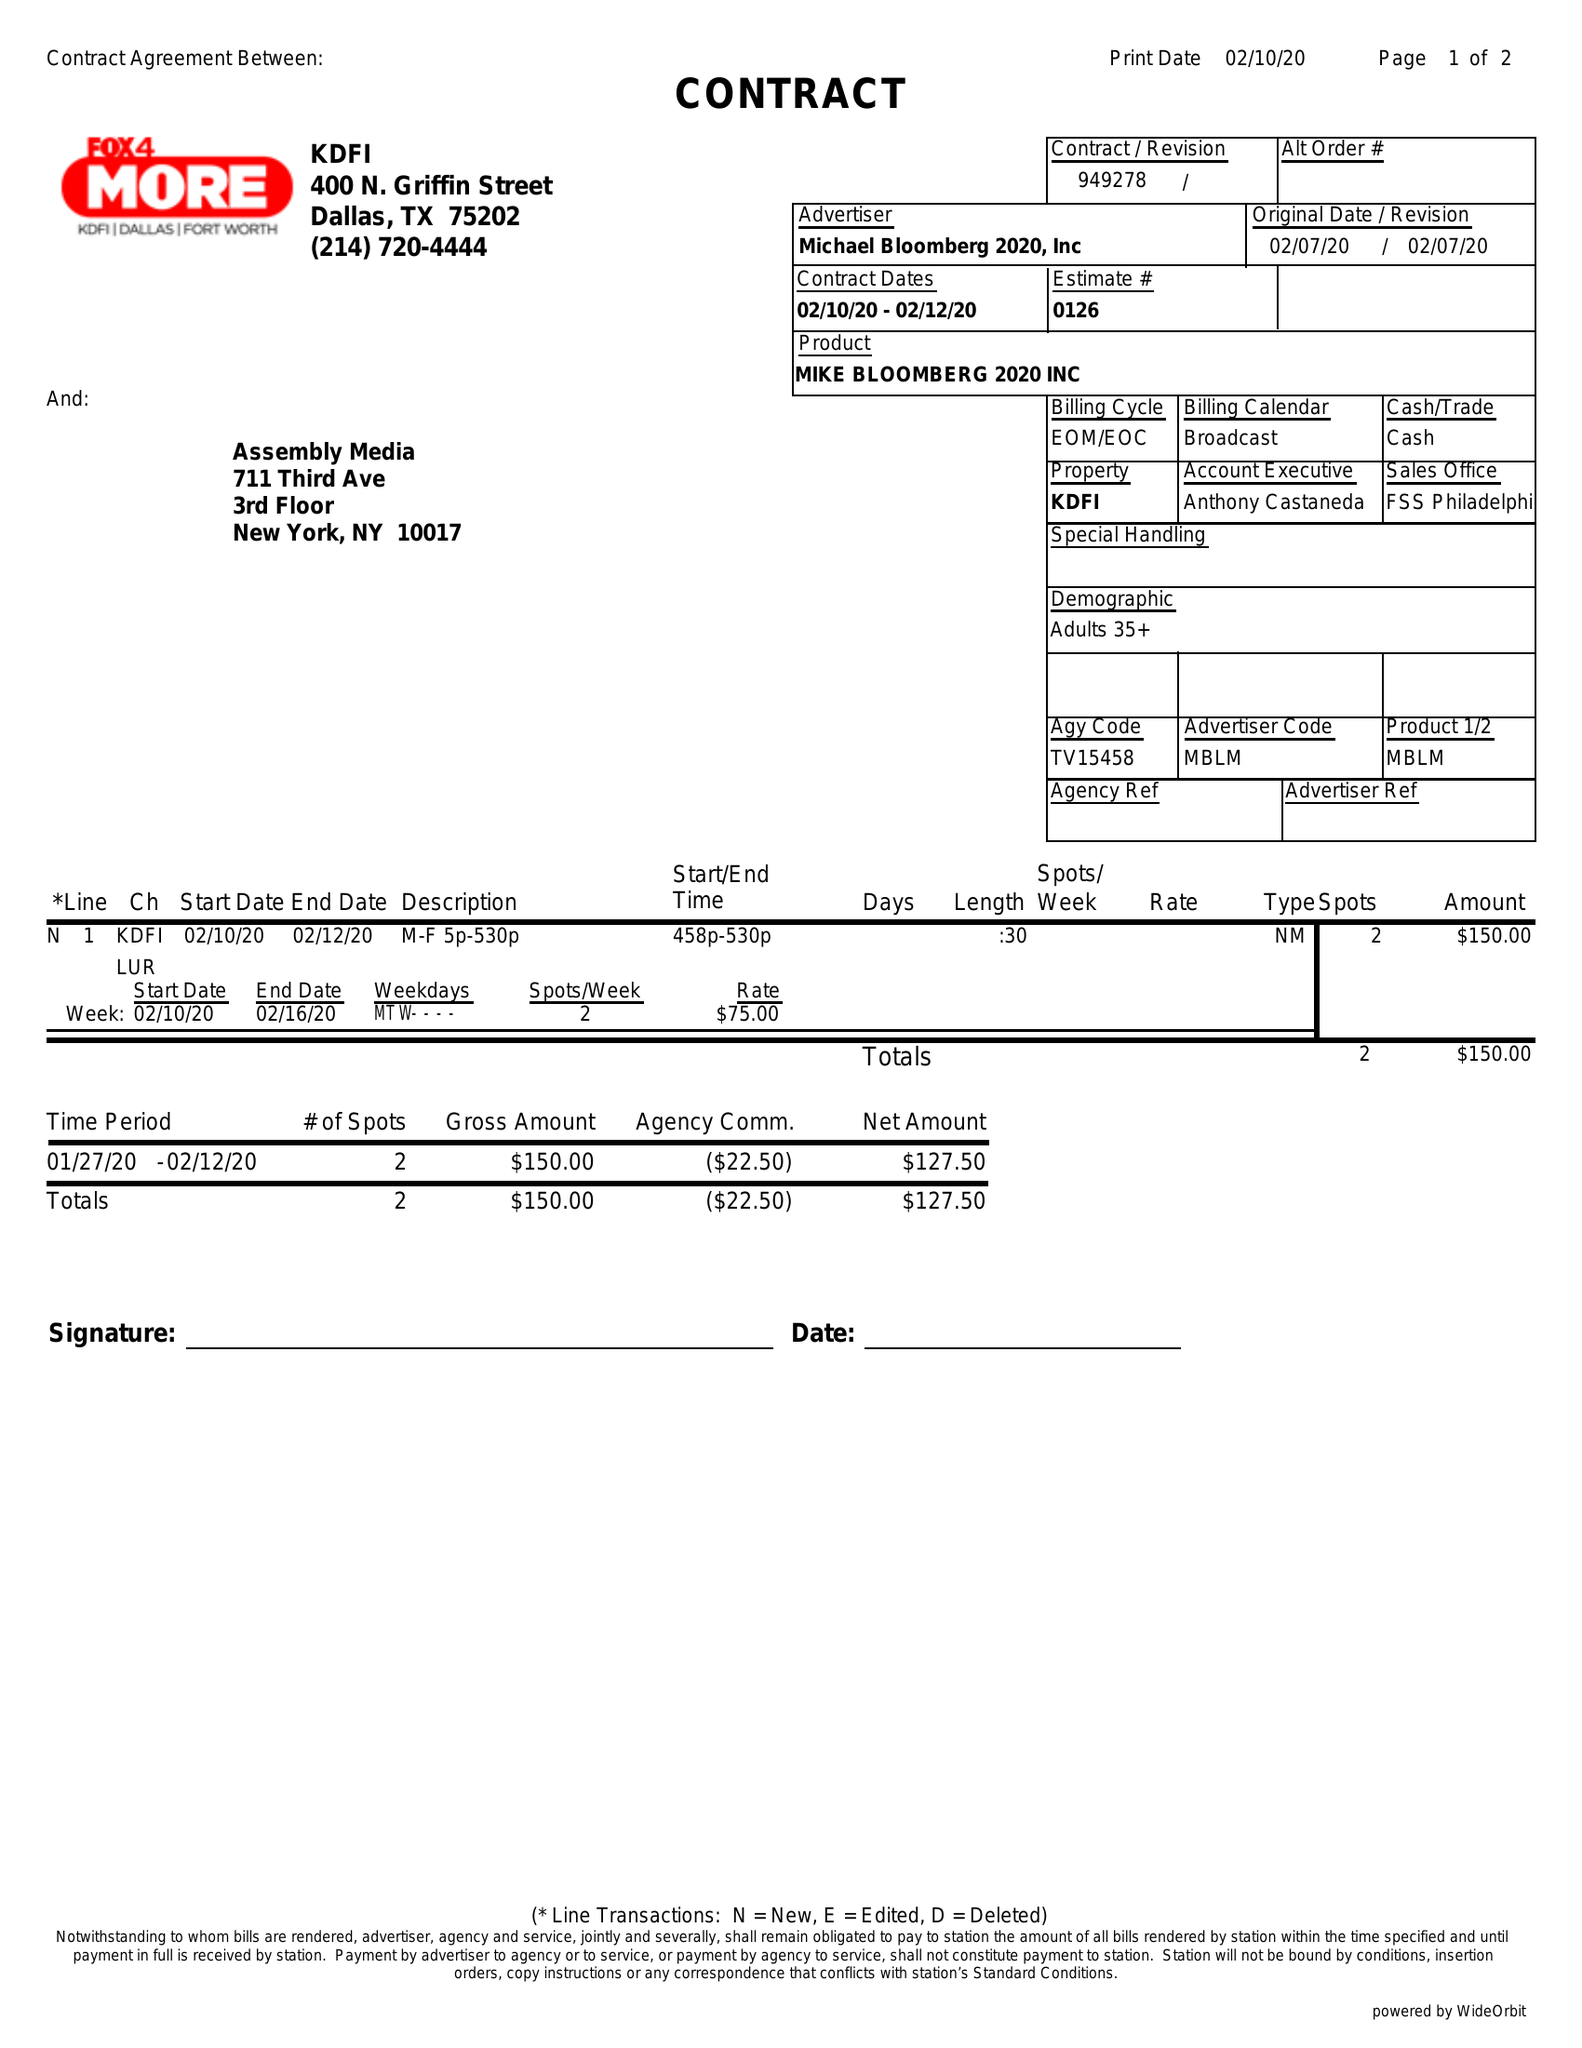What is the value for the advertiser?
Answer the question using a single word or phrase. MICHAEL BLOOMBERG 2020, INC 